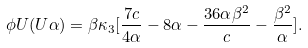<formula> <loc_0><loc_0><loc_500><loc_500>\phi U ( U \alpha ) = \beta \kappa _ { 3 } [ \frac { 7 c } { 4 \alpha } - 8 \alpha - \frac { 3 6 \alpha \beta ^ { 2 } } { c } - \frac { \beta ^ { 2 } } { \alpha } ] .</formula> 